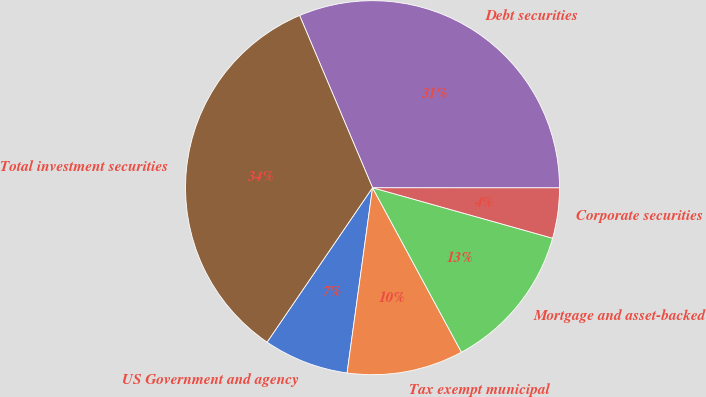Convert chart. <chart><loc_0><loc_0><loc_500><loc_500><pie_chart><fcel>US Government and agency<fcel>Tax exempt municipal<fcel>Mortgage and asset-backed<fcel>Corporate securities<fcel>Debt securities<fcel>Total investment securities<nl><fcel>7.36%<fcel>10.06%<fcel>12.76%<fcel>4.35%<fcel>31.38%<fcel>34.09%<nl></chart> 